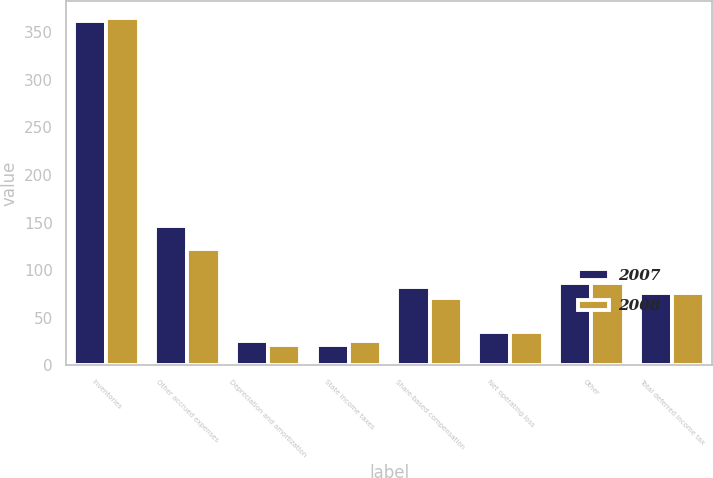<chart> <loc_0><loc_0><loc_500><loc_500><stacked_bar_chart><ecel><fcel>Inventories<fcel>Other accrued expenses<fcel>Depreciation and amortization<fcel>State income taxes<fcel>Share-based compensation<fcel>Net operating loss<fcel>Other<fcel>Total deferred income tax<nl><fcel>2007<fcel>361.8<fcel>146.2<fcel>25.1<fcel>21.3<fcel>82.5<fcel>35.2<fcel>86.9<fcel>76.5<nl><fcel>2008<fcel>365.1<fcel>121.8<fcel>21.7<fcel>25.4<fcel>70.5<fcel>35.4<fcel>86.9<fcel>76.5<nl></chart> 